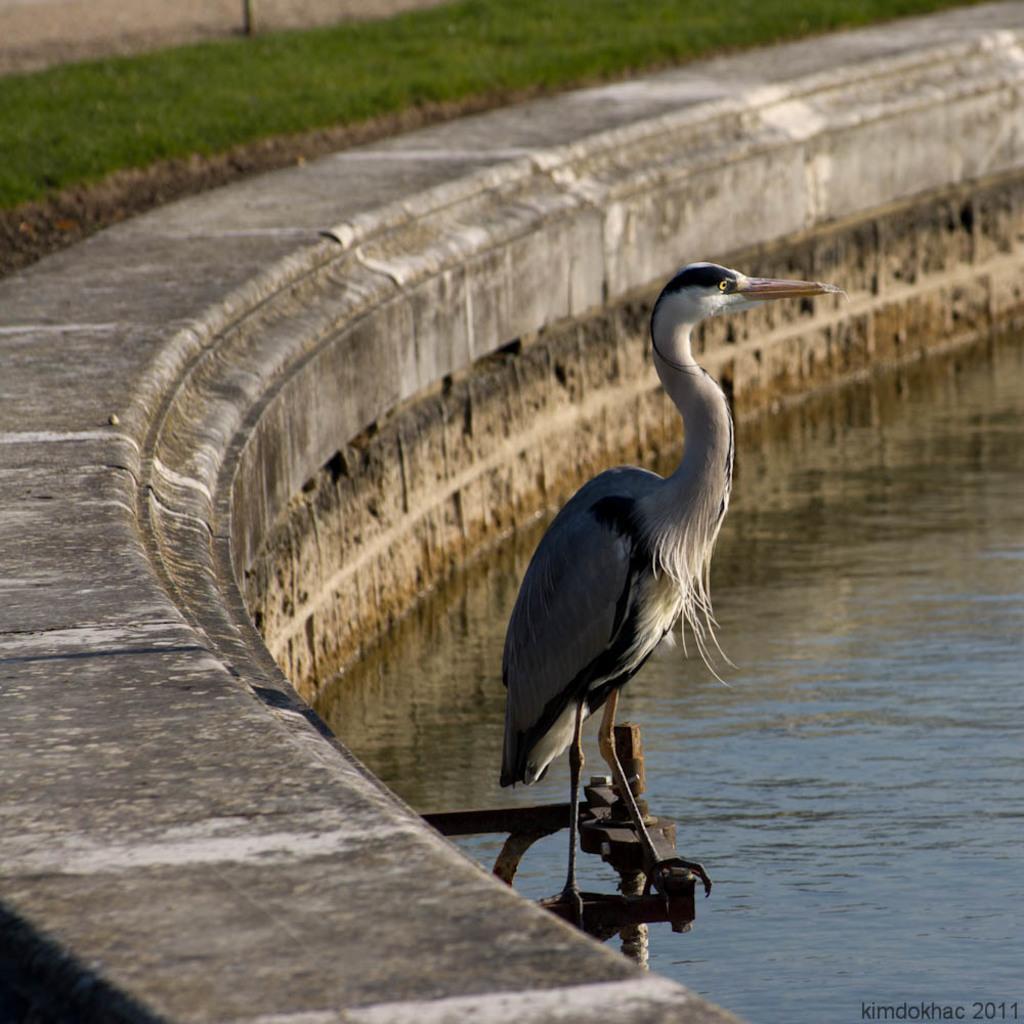Please provide a concise description of this image. In this image we can see a bird on an object, also we can see some water, grass and the wall, at the bottom of the image we can see some text. 